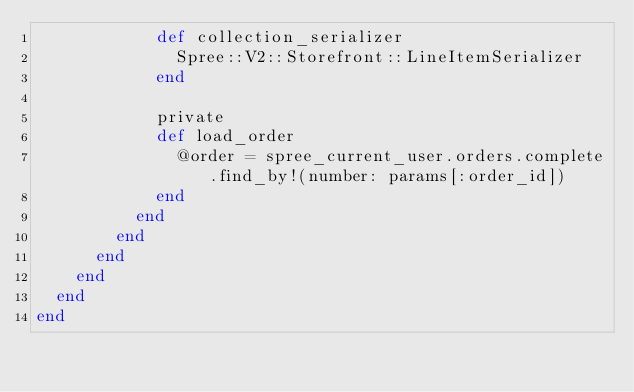Convert code to text. <code><loc_0><loc_0><loc_500><loc_500><_Ruby_>            def collection_serializer
              Spree::V2::Storefront::LineItemSerializer
            end

            private
            def load_order
              @order = spree_current_user.orders.complete.find_by!(number: params[:order_id])
            end
          end
        end
      end
    end
  end
end
</code> 